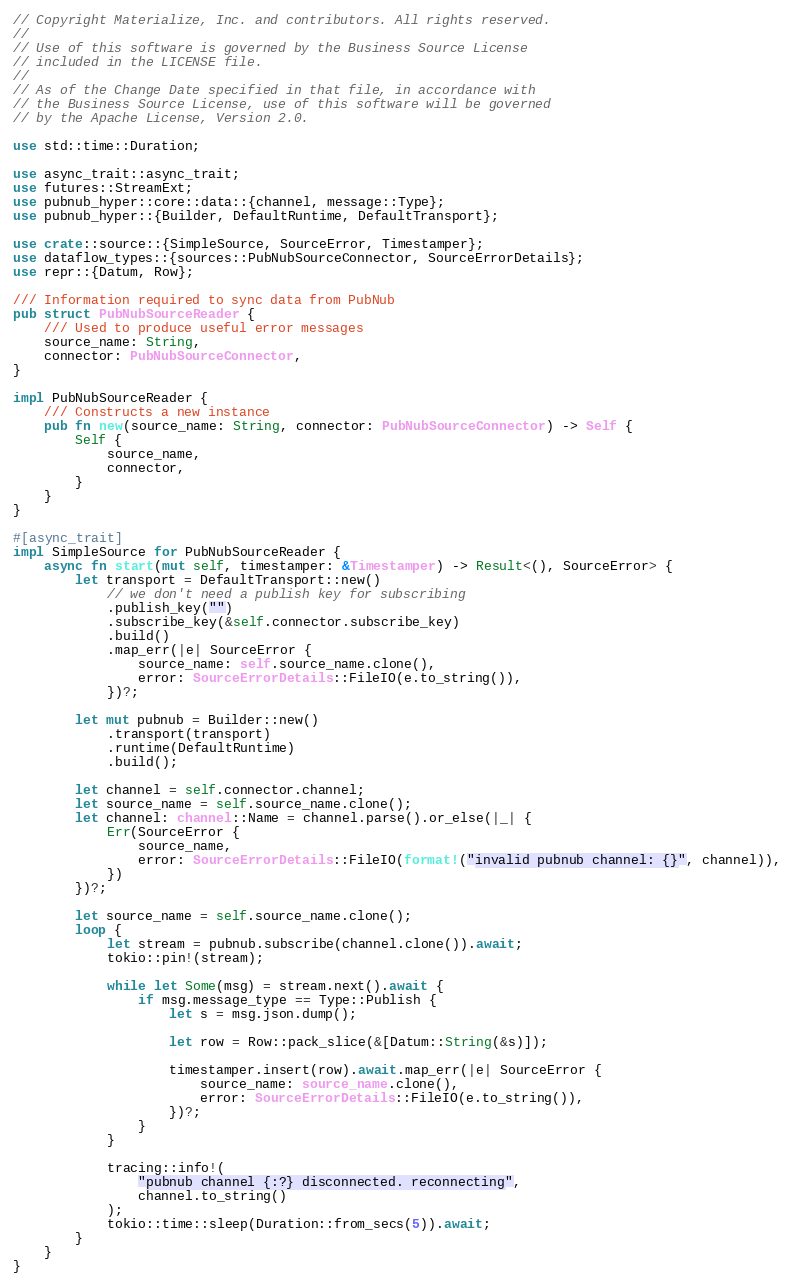<code> <loc_0><loc_0><loc_500><loc_500><_Rust_>// Copyright Materialize, Inc. and contributors. All rights reserved.
//
// Use of this software is governed by the Business Source License
// included in the LICENSE file.
//
// As of the Change Date specified in that file, in accordance with
// the Business Source License, use of this software will be governed
// by the Apache License, Version 2.0.

use std::time::Duration;

use async_trait::async_trait;
use futures::StreamExt;
use pubnub_hyper::core::data::{channel, message::Type};
use pubnub_hyper::{Builder, DefaultRuntime, DefaultTransport};

use crate::source::{SimpleSource, SourceError, Timestamper};
use dataflow_types::{sources::PubNubSourceConnector, SourceErrorDetails};
use repr::{Datum, Row};

/// Information required to sync data from PubNub
pub struct PubNubSourceReader {
    /// Used to produce useful error messages
    source_name: String,
    connector: PubNubSourceConnector,
}

impl PubNubSourceReader {
    /// Constructs a new instance
    pub fn new(source_name: String, connector: PubNubSourceConnector) -> Self {
        Self {
            source_name,
            connector,
        }
    }
}

#[async_trait]
impl SimpleSource for PubNubSourceReader {
    async fn start(mut self, timestamper: &Timestamper) -> Result<(), SourceError> {
        let transport = DefaultTransport::new()
            // we don't need a publish key for subscribing
            .publish_key("")
            .subscribe_key(&self.connector.subscribe_key)
            .build()
            .map_err(|e| SourceError {
                source_name: self.source_name.clone(),
                error: SourceErrorDetails::FileIO(e.to_string()),
            })?;

        let mut pubnub = Builder::new()
            .transport(transport)
            .runtime(DefaultRuntime)
            .build();

        let channel = self.connector.channel;
        let source_name = self.source_name.clone();
        let channel: channel::Name = channel.parse().or_else(|_| {
            Err(SourceError {
                source_name,
                error: SourceErrorDetails::FileIO(format!("invalid pubnub channel: {}", channel)),
            })
        })?;

        let source_name = self.source_name.clone();
        loop {
            let stream = pubnub.subscribe(channel.clone()).await;
            tokio::pin!(stream);

            while let Some(msg) = stream.next().await {
                if msg.message_type == Type::Publish {
                    let s = msg.json.dump();

                    let row = Row::pack_slice(&[Datum::String(&s)]);

                    timestamper.insert(row).await.map_err(|e| SourceError {
                        source_name: source_name.clone(),
                        error: SourceErrorDetails::FileIO(e.to_string()),
                    })?;
                }
            }

            tracing::info!(
                "pubnub channel {:?} disconnected. reconnecting",
                channel.to_string()
            );
            tokio::time::sleep(Duration::from_secs(5)).await;
        }
    }
}
</code> 